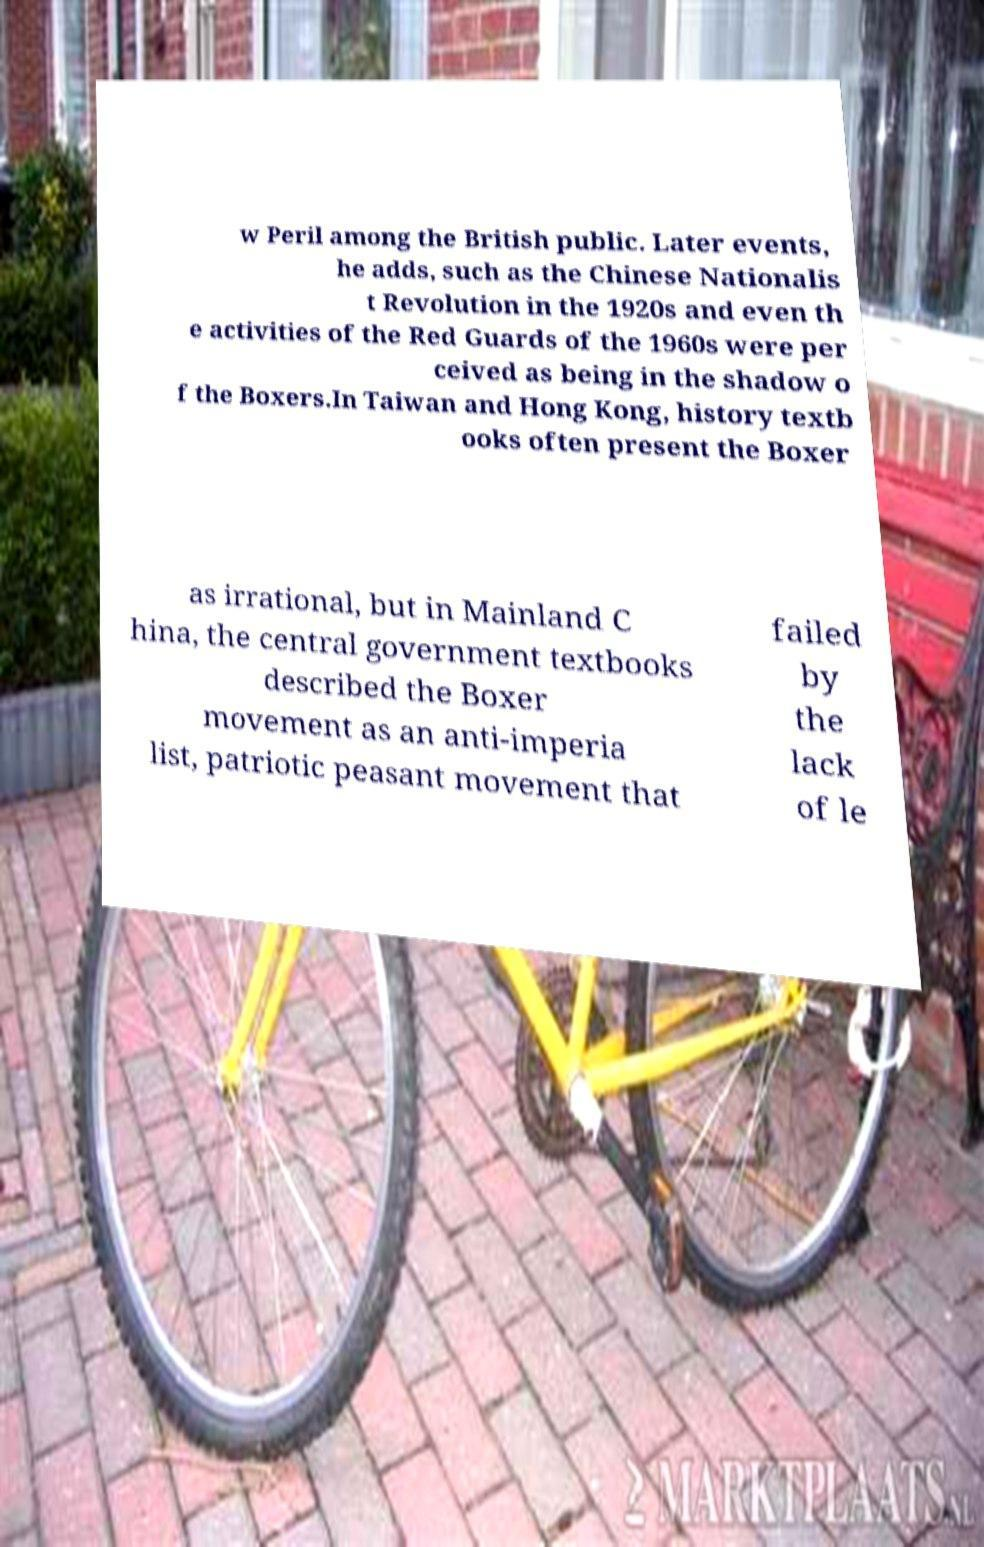What messages or text are displayed in this image? I need them in a readable, typed format. w Peril among the British public. Later events, he adds, such as the Chinese Nationalis t Revolution in the 1920s and even th e activities of the Red Guards of the 1960s were per ceived as being in the shadow o f the Boxers.In Taiwan and Hong Kong, history textb ooks often present the Boxer as irrational, but in Mainland C hina, the central government textbooks described the Boxer movement as an anti-imperia list, patriotic peasant movement that failed by the lack of le 